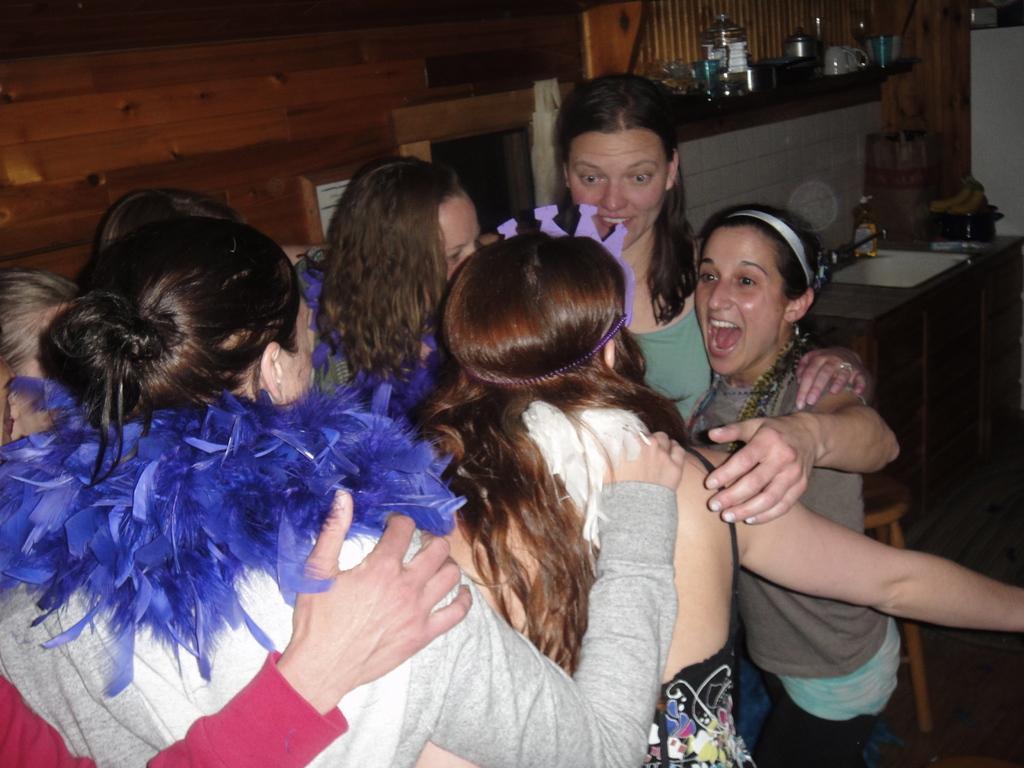Can you describe this image briefly? There are group of people standing. This looks like a table with a bottle, bowl and few other objects on it. This looks like a chair. I can see a kettle, utensils and few other things are placed on the cabin. This looks like a wooden wall. 